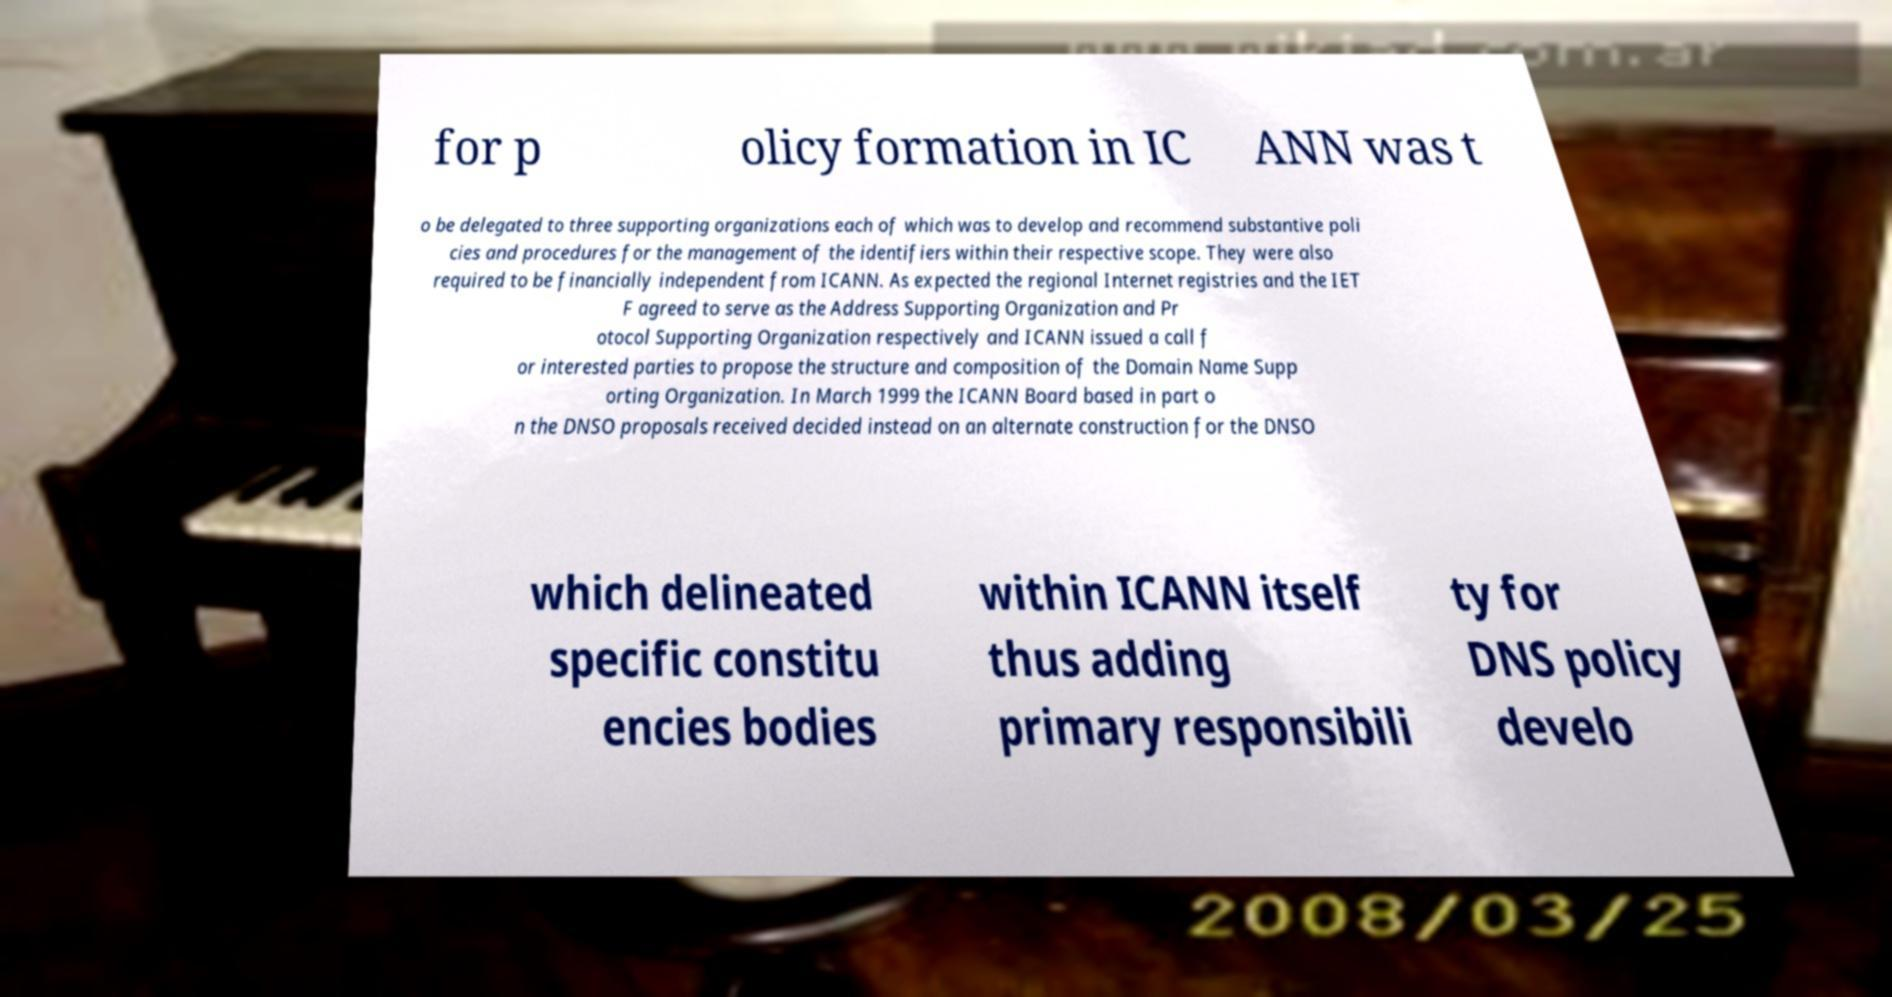Please read and relay the text visible in this image. What does it say? for p olicy formation in IC ANN was t o be delegated to three supporting organizations each of which was to develop and recommend substantive poli cies and procedures for the management of the identifiers within their respective scope. They were also required to be financially independent from ICANN. As expected the regional Internet registries and the IET F agreed to serve as the Address Supporting Organization and Pr otocol Supporting Organization respectively and ICANN issued a call f or interested parties to propose the structure and composition of the Domain Name Supp orting Organization. In March 1999 the ICANN Board based in part o n the DNSO proposals received decided instead on an alternate construction for the DNSO which delineated specific constitu encies bodies within ICANN itself thus adding primary responsibili ty for DNS policy develo 